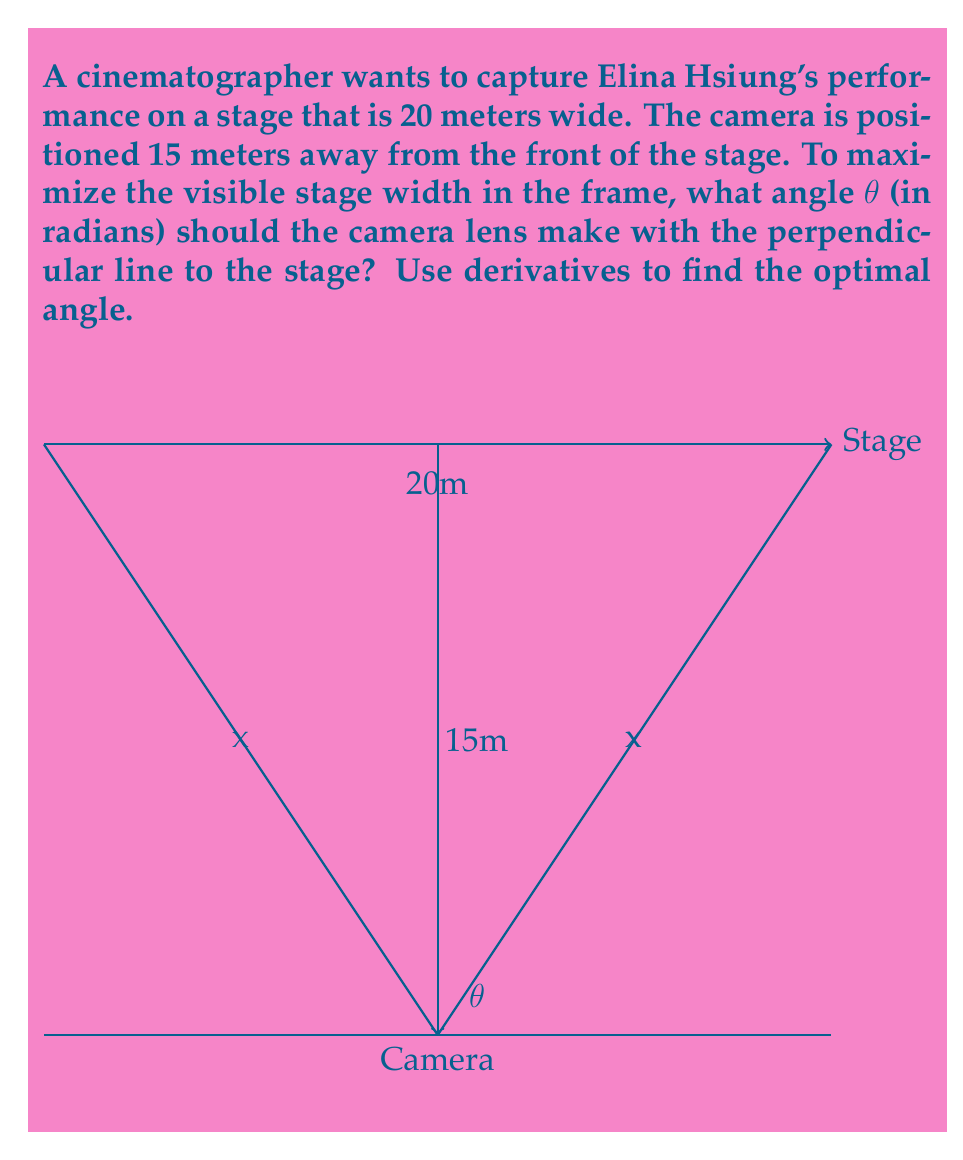Solve this math problem. Let's approach this step-by-step:

1) First, we need to express the visible width of the stage as a function of the angle θ. Let's call this width W(θ).

2) From the diagram, we can see that half of the visible width is x, where:

   $$ \tan(\theta) = \frac{x}{15} $$

3) Solving for x:

   $$ x = 15 \tan(\theta) $$

4) The total visible width W(θ) is twice this:

   $$ W(\theta) = 2x = 30 \tan(\theta) $$

5) However, this is only valid until the camera can see the entire stage. The maximum occurs when:

   $$ 30 \tan(\theta) = 20 $$

6) To find the maximum, we need to differentiate W(θ) with respect to θ:

   $$ \frac{d}{d\theta}W(\theta) = 30 \sec^2(\theta) $$

7) Set this derivative to zero to find the critical point:

   $$ 30 \sec^2(\theta) = 0 $$

   This equation has no solution, meaning there's no maximum within the valid range.

8) Therefore, the maximum occurs at the boundary of our constraint:

   $$ 30 \tan(\theta) = 20 $$
   $$ \tan(\theta) = \frac{2}{3} $$
   $$ \theta = \arctan(\frac{2}{3}) $$

9) This angle maximizes the visible width of the stage in the camera frame.
Answer: $\arctan(\frac{2}{3})$ radians 